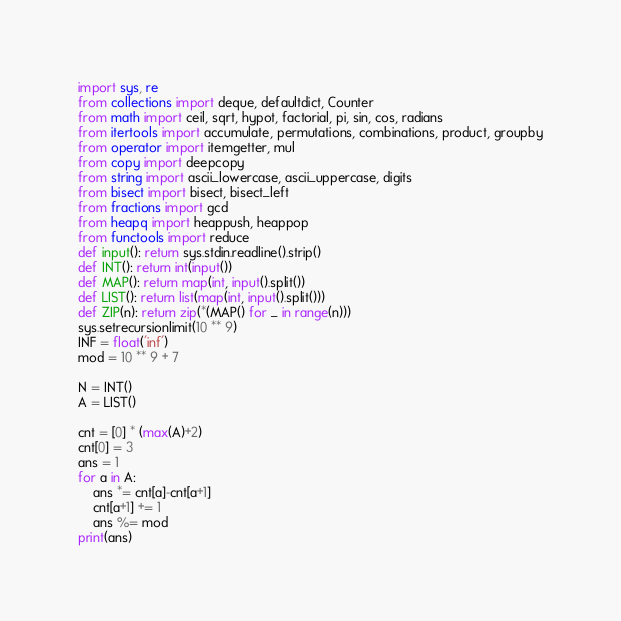Convert code to text. <code><loc_0><loc_0><loc_500><loc_500><_Python_>import sys, re
from collections import deque, defaultdict, Counter
from math import ceil, sqrt, hypot, factorial, pi, sin, cos, radians
from itertools import accumulate, permutations, combinations, product, groupby
from operator import itemgetter, mul
from copy import deepcopy
from string import ascii_lowercase, ascii_uppercase, digits
from bisect import bisect, bisect_left
from fractions import gcd
from heapq import heappush, heappop
from functools import reduce
def input(): return sys.stdin.readline().strip()
def INT(): return int(input())
def MAP(): return map(int, input().split())
def LIST(): return list(map(int, input().split()))
def ZIP(n): return zip(*(MAP() for _ in range(n)))
sys.setrecursionlimit(10 ** 9)
INF = float('inf')
mod = 10 ** 9 + 7

N = INT()
A = LIST()

cnt = [0] * (max(A)+2)
cnt[0] = 3
ans = 1
for a in A:
	ans *= cnt[a]-cnt[a+1]
	cnt[a+1] += 1
	ans %= mod
print(ans)
</code> 